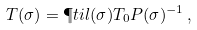<formula> <loc_0><loc_0><loc_500><loc_500>T ( \sigma ) = \P t i l ( \sigma ) T _ { 0 } P ( \sigma ) ^ { - 1 } \, ,</formula> 